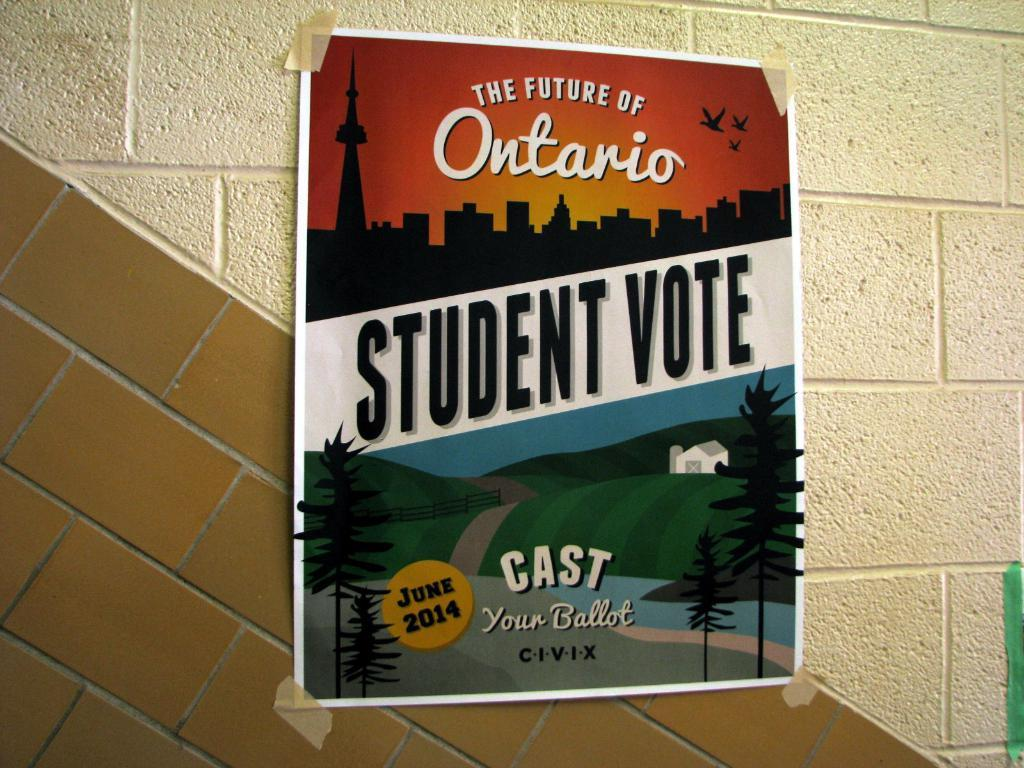<image>
Offer a succinct explanation of the picture presented. a poster on the wall that says student vote on it 